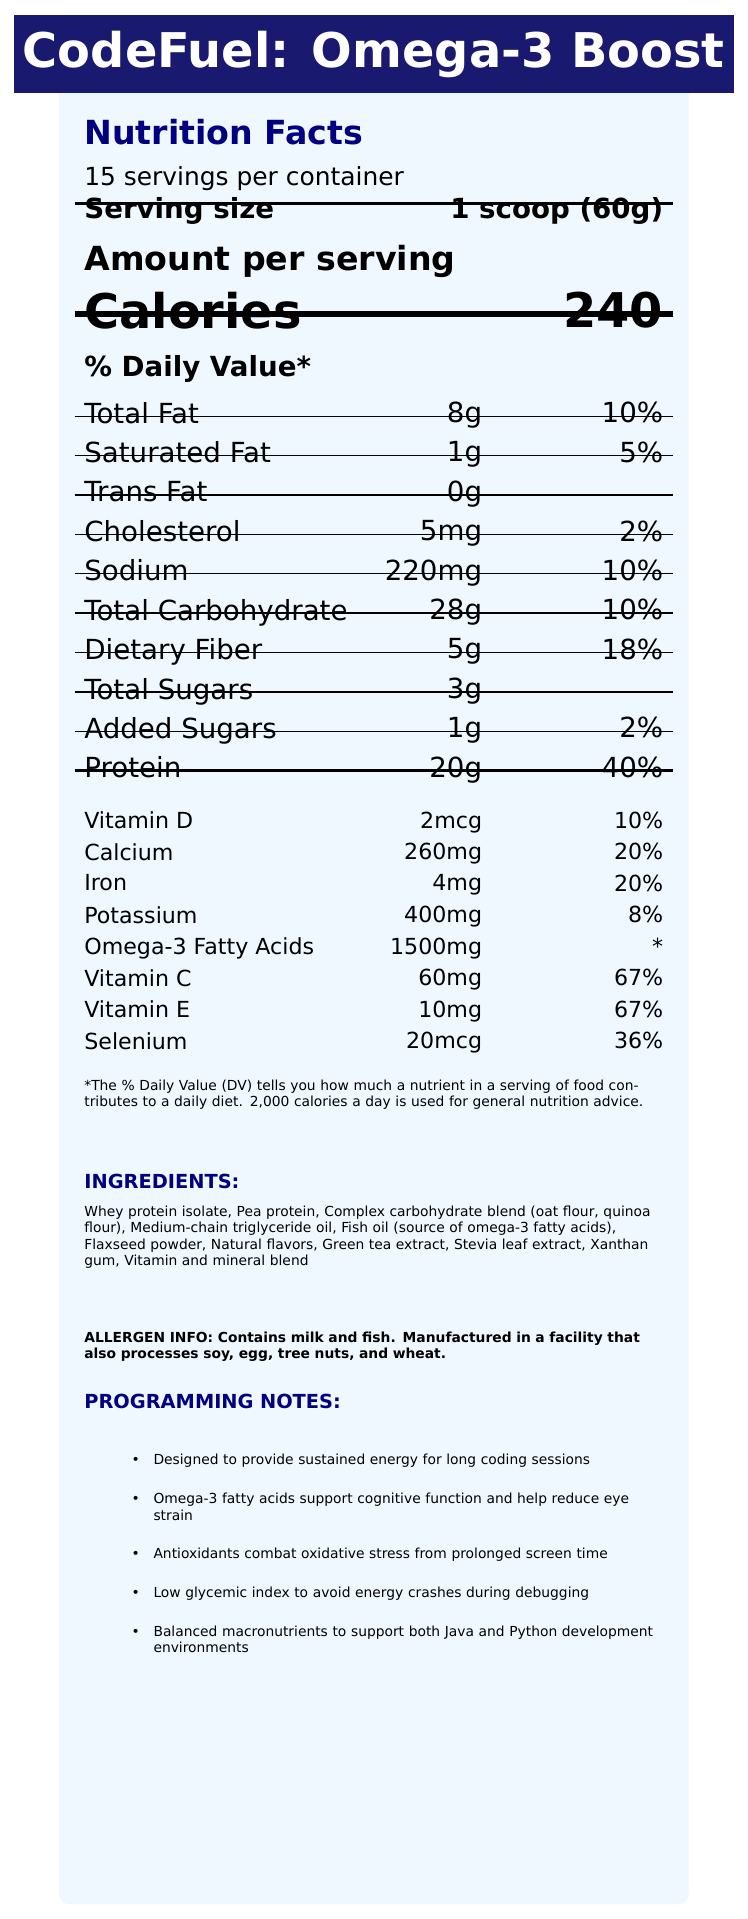what is the total number of servings per container? The document states "15 servings per container."
Answer: 15 how many calories are there per serving? Under the "Amount per serving" section, it mentions "Calories 240."
Answer: 240 what is the serving size? The document lists the serving size as "1 scoop (60g)."
Answer: 1 scoop (60g) how many grams of total fat are in one serving? In the \% Daily Value* section, it's stated as "Total Fat 8g."
Answer: 8g how much protein is there per serving? The document indicates "Protein 20g" under the \% Daily Value* section.
Answer: 20g what is the daily value percentage of calcium per serving? The document lists "Calcium 20%" in the lower section of the label.
Answer: 20% which ingredient provides omega-3 fatty acids? A. Whey protein isolate B. Pea protein C. Fish oil D. Green tea extract The ingredients list includes "Fish oil (source of omega-3 fatty acids)."
Answer: C how many milligrams of sodium does each serving contain? The document states "Sodium 220mg" under the \% Daily Value* section.
Answer: 220mg what are the main antioxidants included in the shake? A. Vitamin C and E B. Vitamin D and Calcium C. Iron and Selenium D. Potassium and Omega-3 The document lists "Vitamin C 60mg (67%), Vitamin E 10mg (67%)" under antioxidants.
Answer: A does the shake contain any trans fats? The document specifies "Trans Fat 0g."
Answer: No what is the primary function of omega-3 fatty acids in this shake? The programming notes mention that "Omega-3 fatty acids support cognitive function and help reduce eye strain."
Answer: Support cognitive function and help reduce eye strain what is the dietary fiber amount per serving? The document indicates "Dietary Fiber 5g" under the \% Daily Value* section.
Answer: 5g is this product suitable for someone with a soy allergy? The allergen info states that it is "Manufactured in a facility that also processes soy."
Answer: No does the product contain added sugars? The document mentions "Added Sugars 1g (2%)" in the \% Daily Value* section.
Answer: Yes summarize the main idea of the nutrition facts label. The document details the nutritional contents of CodeFuel: Omega-3 Boost, a meal replacement shake emphasizing sustained energy and enhanced cognitive function for programmers. It includes detailed nutritional facts, ingredient lists, allergen information, and specific programming-related benefits.
Answer: CodeFuel: Omega-3 Boost is a meal replacement shake designed for programmers, providing 240 calories per serving with balanced macronutrients, added omega-3 fatty acids, and antioxidants such as Vitamin C and E. The shake supports sustained energy and cognitive function, with 20g of protein, and is manufactured in a facility that processes multiple allergens. what are the benefits of antioxidants in the shake? The programming notes highlight that "Antioxidants combat oxidative stress from prolonged screen time."
Answer: Combat oxidative stress from prolonged screen time what is the daily percentage value of selenium per serving? The document lists "Selenium 20mcg (36%)" under antioxidants.
Answer: 36% how many milligrams of potassium are in one serving? The document indicates "Potassium 400mg (8%)."
Answer: 400mg five people want to consume this shake each day for a week. how many containers do they need to buy? There are 15 servings per container, and five people each consuming it every day for a week (5*7=35 servings total), so they would need three containers (35 servings / 15 servings per container ≈ 2.33, round up to 3).
Answer: 3 containers how many grams of sugar are in one serving? The document states "Total Sugars 3g" under the \% Daily Value* section.
Answer: 3g does the shake contain any tree nuts? The allergen info states it is "Manufactured in a facility that also processes tree nuts," but doesn't specify if tree nuts are in the ingredients.
Answer: Cannot be determined which nutrient has the highest daily value percentage per serving? Among the nutrients listed, protein has the highest daily value percentage at "40%."
Answer: Protein (40%) do the ingredients include any artificial sweeteners? The document lists "Stevia leaf extract" as a natural sweetener.
Answer: No 